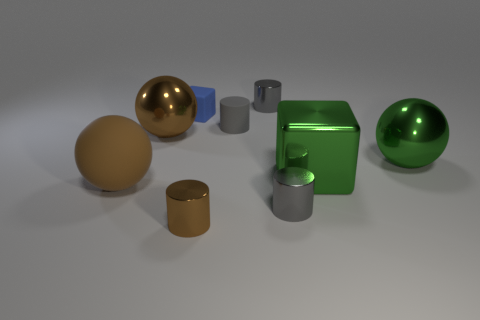How many other objects are the same color as the large block?
Provide a succinct answer. 1. Do the tiny matte cylinder and the matte sphere have the same color?
Your answer should be very brief. No. Is there anything else that is the same shape as the blue object?
Make the answer very short. Yes. There is a cylinder that is the same color as the large rubber object; what material is it?
Your answer should be very brief. Metal. Is the number of tiny gray metallic objects behind the brown rubber ball the same as the number of spheres?
Ensure brevity in your answer.  No. Are there any gray metal cylinders in front of the gray matte cylinder?
Offer a terse response. Yes. Is the shape of the gray matte thing the same as the tiny object behind the tiny cube?
Give a very brief answer. Yes. What color is the big cube that is made of the same material as the big green sphere?
Give a very brief answer. Green. What color is the small matte cube?
Make the answer very short. Blue. Do the tiny cube and the large ball in front of the large green metallic sphere have the same material?
Ensure brevity in your answer.  Yes. 